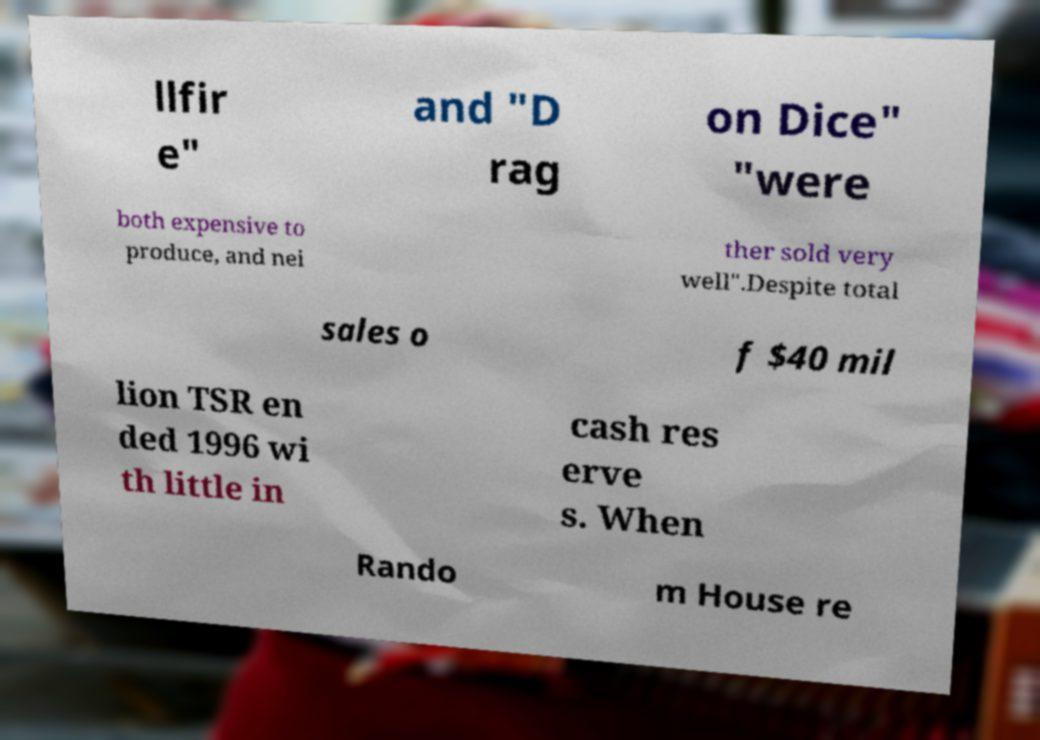Please identify and transcribe the text found in this image. llfir e" and "D rag on Dice" "were both expensive to produce, and nei ther sold very well".Despite total sales o f $40 mil lion TSR en ded 1996 wi th little in cash res erve s. When Rando m House re 